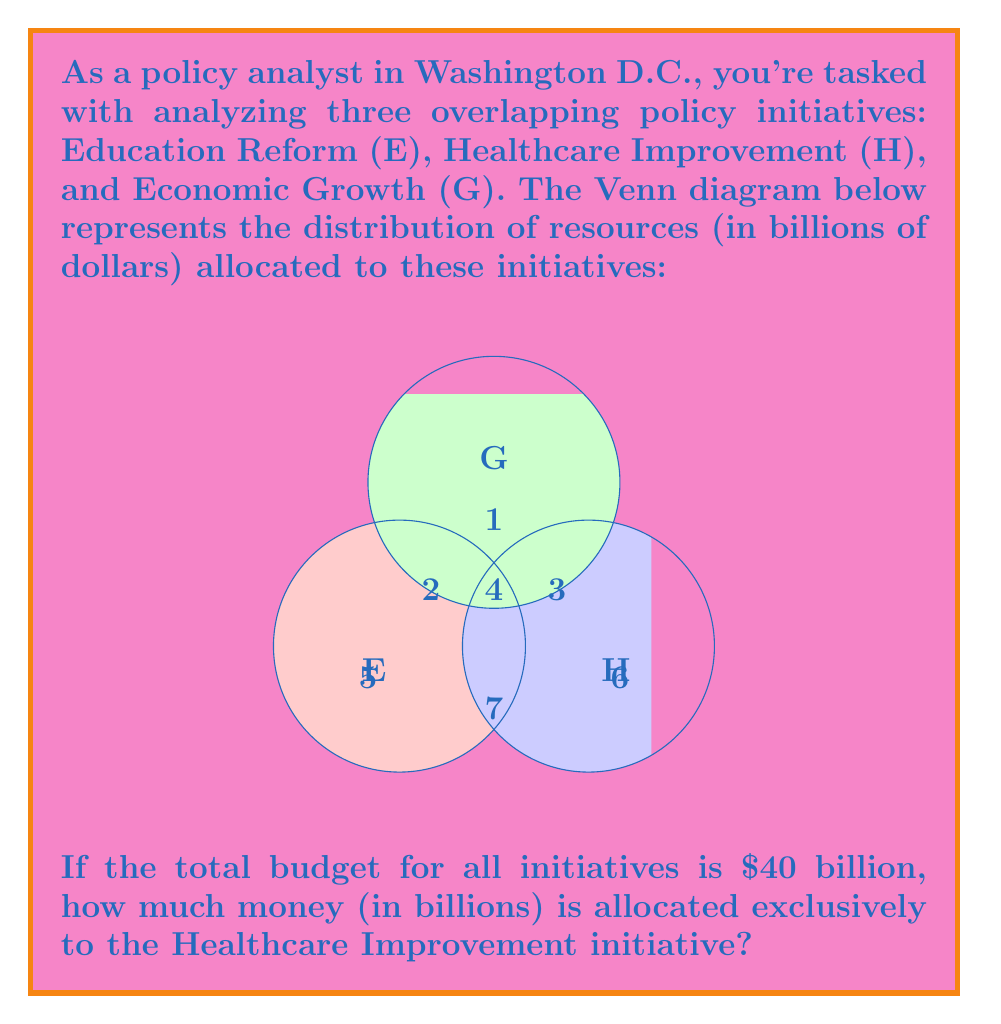Can you answer this question? Let's approach this step-by-step:

1) First, let's define our sets:
   E: Education Reform
   H: Healthcare Improvement
   G: Economic Growth

2) From the Venn diagram, we can see the distribution of resources:
   - $2 billion for E ∩ G (not H)
   - $3 billion for H ∩ G (not E)
   - $1 billion for E ∩ H ∩ G
   - $4 billion for E ∩ H (not G)
   - $5 billion for E only
   - $6 billion for H only
   - $7 billion for G only

3) To find the amount allocated exclusively to Healthcare Improvement, we need to find the value of the region labeled "6" in the diagram.

4) We can use the given information that the total budget is $40 billion. Let's call the unknown amount x.

5) We can set up an equation:

   $$(5 + 2 + 4 + 1 + 3 + 7) + x + 6 = 40$$

6) Simplify:

   $$22 + x + 6 = 40$$
   $$28 + x = 40$$

7) Solve for x:

   $$x = 40 - 28 = 12$$

Therefore, $12 billion is allocated exclusively to the Healthcare Improvement initiative.
Answer: $12 billion 